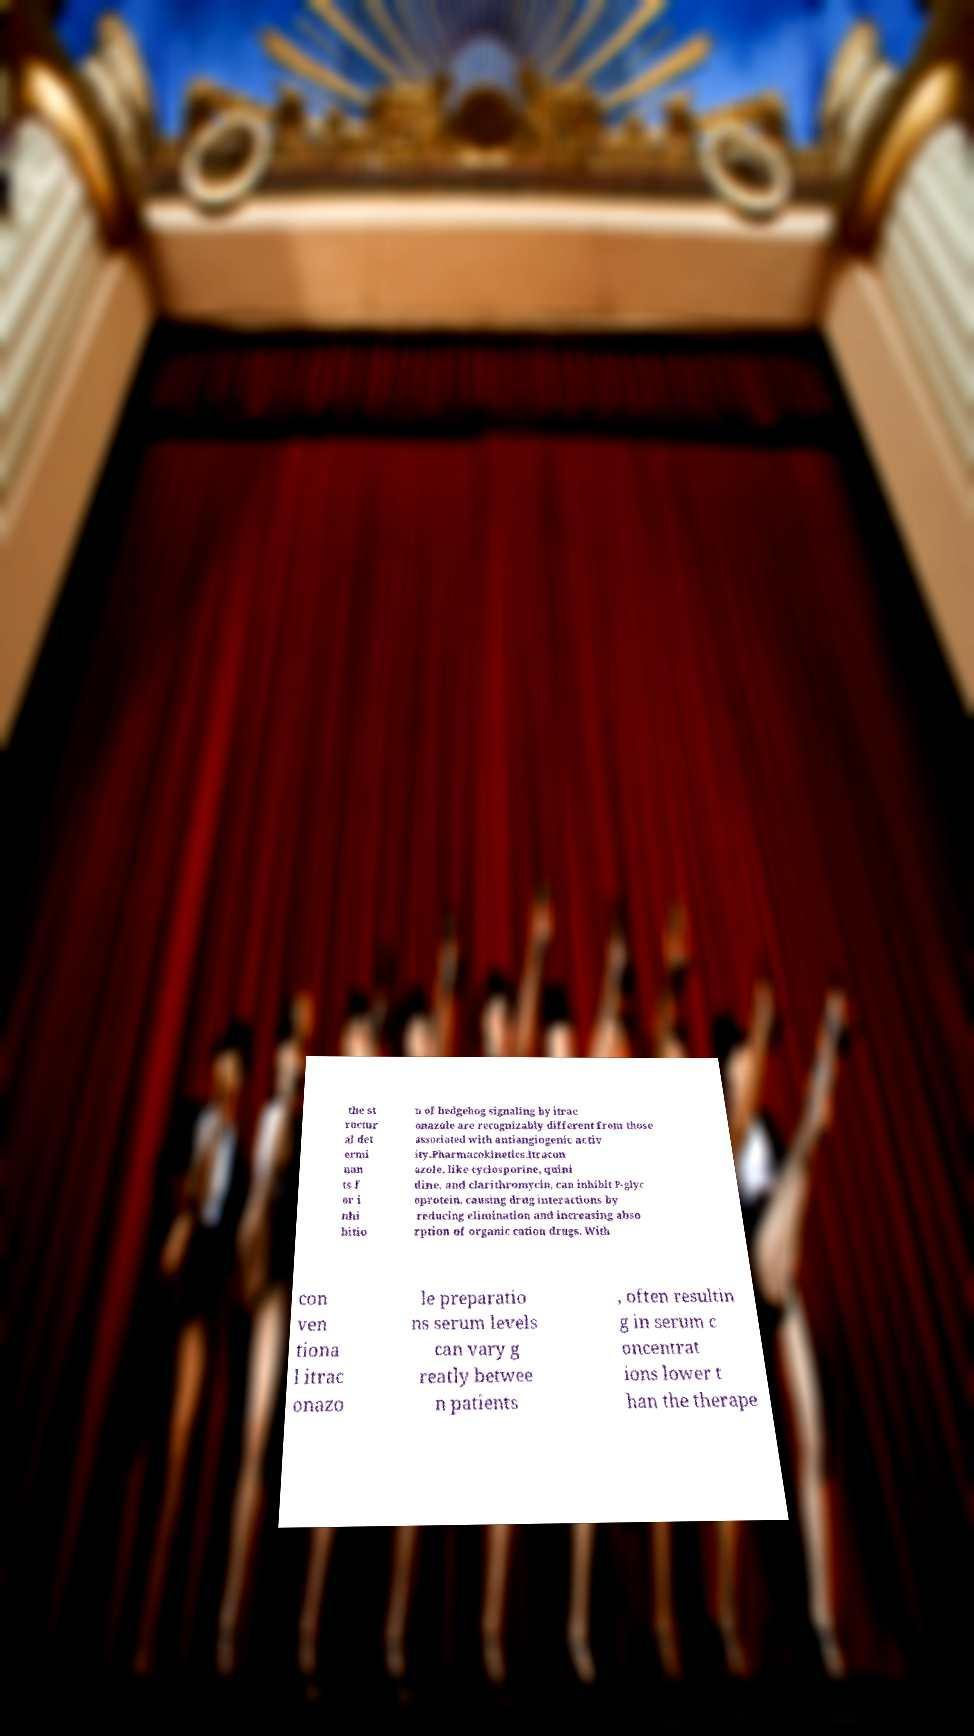Could you assist in decoding the text presented in this image and type it out clearly? the st ructur al det ermi nan ts f or i nhi bitio n of hedgehog signaling by itrac onazole are recognizably different from those associated with antiangiogenic activ ity.Pharmacokinetics.Itracon azole, like cyclosporine, quini dine, and clarithromycin, can inhibit P-glyc oprotein, causing drug interactions by reducing elimination and increasing abso rption of organic cation drugs. With con ven tiona l itrac onazo le preparatio ns serum levels can vary g reatly betwee n patients , often resultin g in serum c oncentrat ions lower t han the therape 